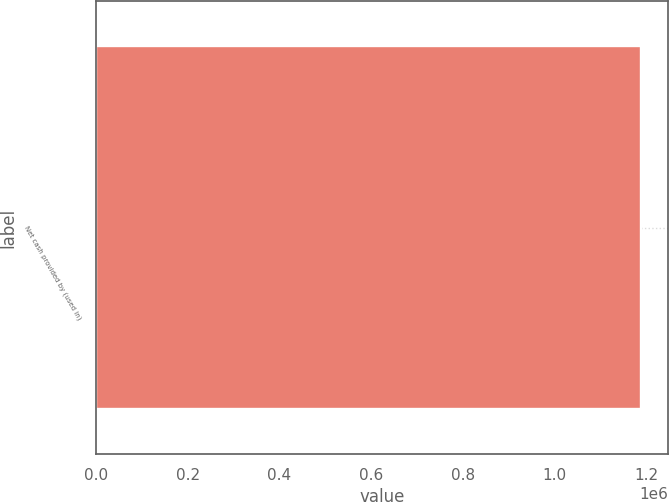<chart> <loc_0><loc_0><loc_500><loc_500><bar_chart><fcel>Net cash provided by (used in)<nl><fcel>1.18694e+06<nl></chart> 